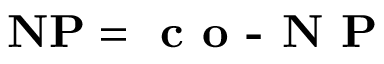Convert formula to latex. <formula><loc_0><loc_0><loc_500><loc_500>N P = { c o - N P }</formula> 